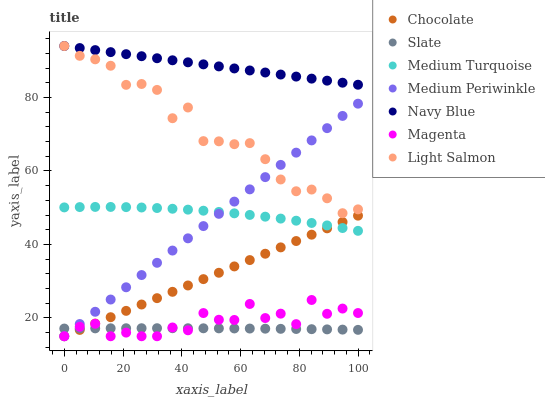Does Slate have the minimum area under the curve?
Answer yes or no. Yes. Does Navy Blue have the maximum area under the curve?
Answer yes or no. Yes. Does Navy Blue have the minimum area under the curve?
Answer yes or no. No. Does Slate have the maximum area under the curve?
Answer yes or no. No. Is Chocolate the smoothest?
Answer yes or no. Yes. Is Magenta the roughest?
Answer yes or no. Yes. Is Navy Blue the smoothest?
Answer yes or no. No. Is Navy Blue the roughest?
Answer yes or no. No. Does Medium Periwinkle have the lowest value?
Answer yes or no. Yes. Does Slate have the lowest value?
Answer yes or no. No. Does Navy Blue have the highest value?
Answer yes or no. Yes. Does Slate have the highest value?
Answer yes or no. No. Is Medium Turquoise less than Navy Blue?
Answer yes or no. Yes. Is Navy Blue greater than Slate?
Answer yes or no. Yes. Does Navy Blue intersect Light Salmon?
Answer yes or no. Yes. Is Navy Blue less than Light Salmon?
Answer yes or no. No. Is Navy Blue greater than Light Salmon?
Answer yes or no. No. Does Medium Turquoise intersect Navy Blue?
Answer yes or no. No. 